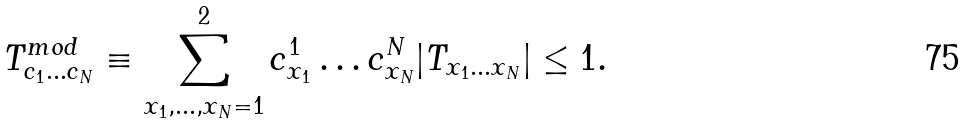<formula> <loc_0><loc_0><loc_500><loc_500>T ^ { m o d } _ { c _ { 1 } \dots c _ { N } } \equiv \sum _ { x _ { 1 } , \dots , x _ { N } = 1 } ^ { 2 } c ^ { 1 } _ { x _ { 1 } } \dots c ^ { N } _ { x _ { N } } | T _ { x _ { 1 } \dots x _ { N } } | \leq 1 .</formula> 